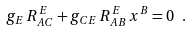Convert formula to latex. <formula><loc_0><loc_0><loc_500><loc_500>g _ { E } \, R _ { A C } ^ { E } + g _ { C E } \, R _ { A B } ^ { E } \, x ^ { B } = 0 \ .</formula> 